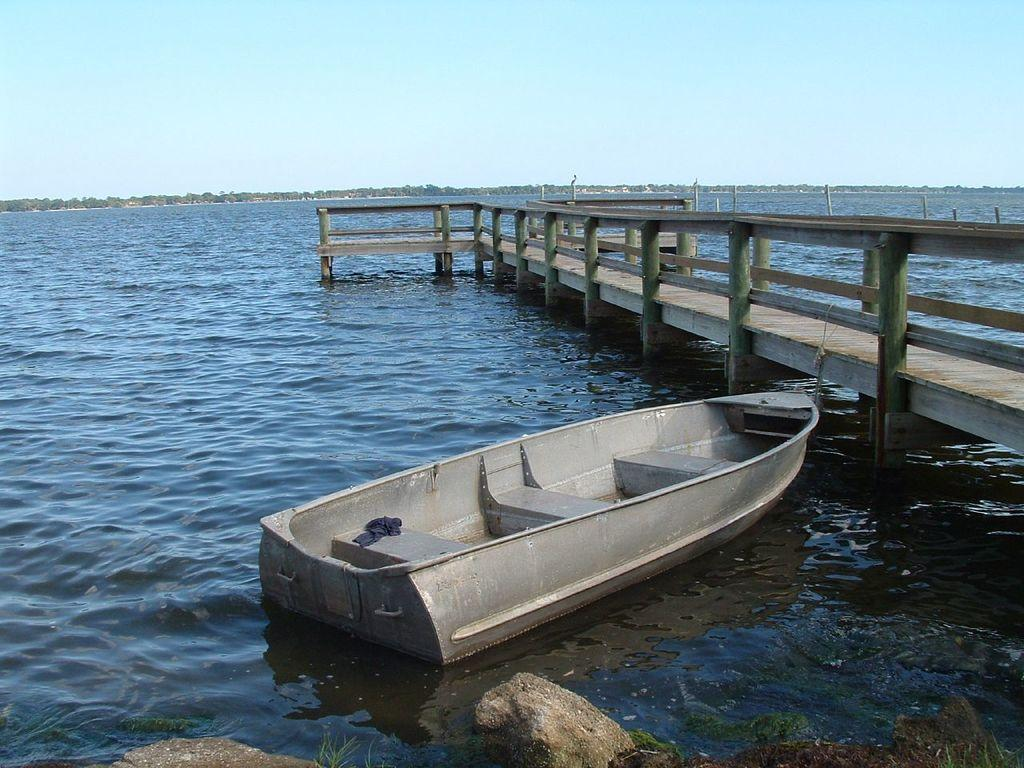What is floating on the water in the image? There is a boat on the surface of the water in the image. What type of objects can be seen on the ground in the image? There are stones visible in the image. What type of vegetation is present in the image? There is grass in the image. What type of structure is present in the image? There is a bridge in the image. What can be seen in the background of the image? There are trees in the background of the image. What is visible at the top of the image? The sky is visible at the top of the image. Where are the cakes placed in the image? There are no cakes present in the image. What type of animal is walking across the bridge in the image? There is no animal, such as a zebra, present in the image. 